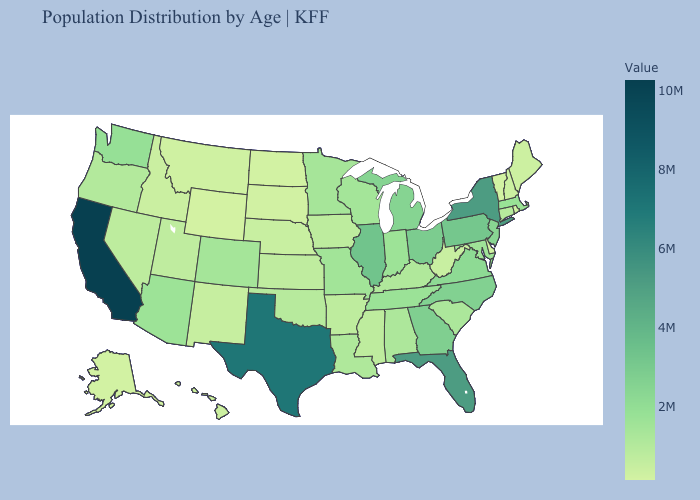Does Tennessee have a higher value than Ohio?
Give a very brief answer. No. Does California have the highest value in the USA?
Short answer required. Yes. Is the legend a continuous bar?
Write a very short answer. Yes. Which states have the lowest value in the South?
Quick response, please. Delaware. Does Maine have the lowest value in the USA?
Quick response, please. No. 